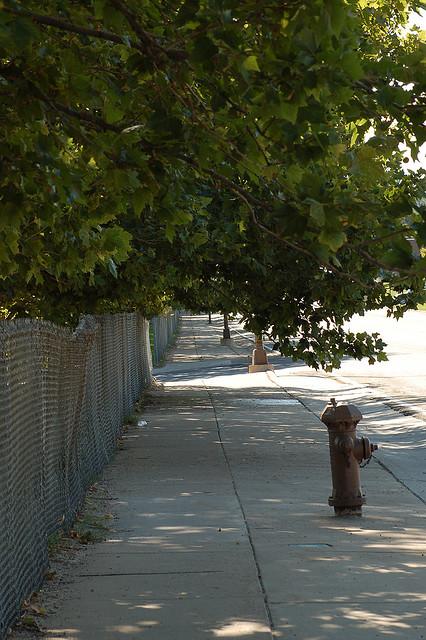What is the likely season depicted in the image? Given the full foliage on the trees and the presence of fallen leaves, it's probably late spring or early autumn. Could this be an urban or suburban area? The style of the fire hydrant, the paved sidewalk, and the chain-link fence suggest it is more likely an urban setting. 